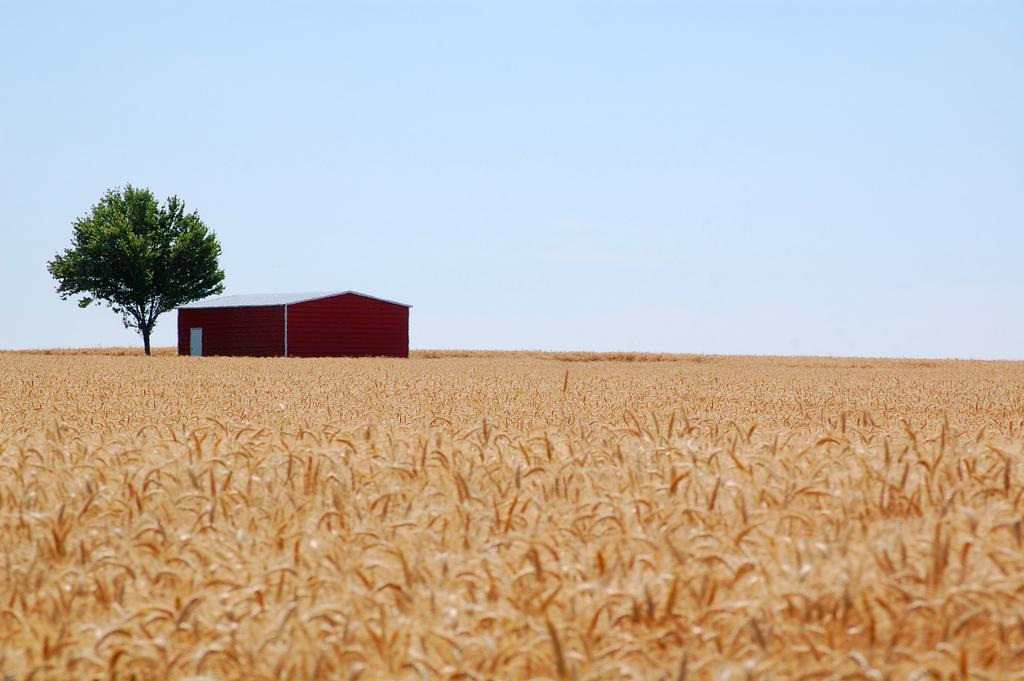What type of landscape is visible in the image? There is a field in the image. What type of structure is present in the image? There is a house in the image. What type of plant life is visible in the image? There is a tree in the image. What is visible at the top of the image? The sky is visible in the image. Where is the quicksand located in the image? There is no quicksand present in the image. What title is given to the house in the image? There is no title given to the house in the image. 